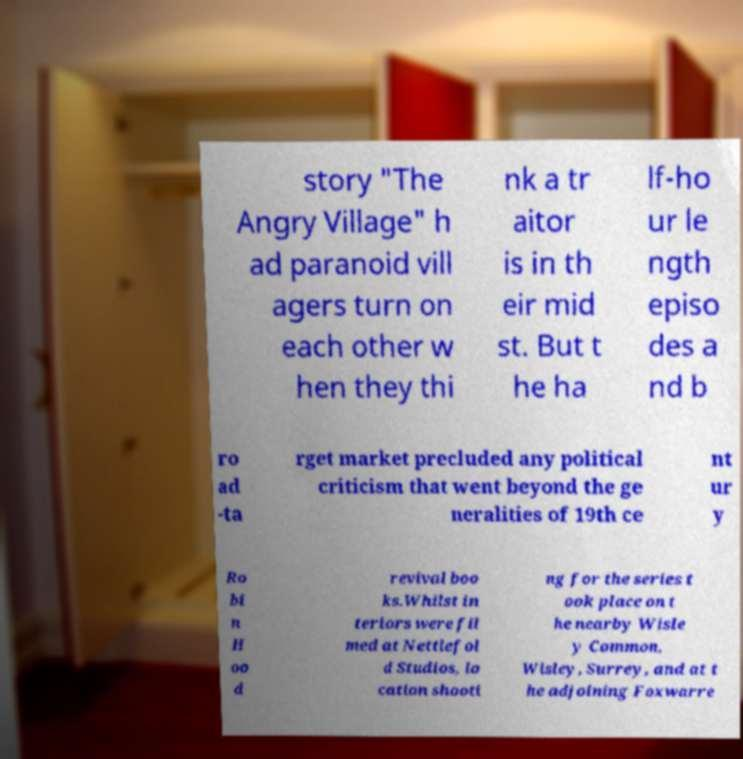Can you read and provide the text displayed in the image?This photo seems to have some interesting text. Can you extract and type it out for me? story "The Angry Village" h ad paranoid vill agers turn on each other w hen they thi nk a tr aitor is in th eir mid st. But t he ha lf-ho ur le ngth episo des a nd b ro ad -ta rget market precluded any political criticism that went beyond the ge neralities of 19th ce nt ur y Ro bi n H oo d revival boo ks.Whilst in teriors were fil med at Nettlefol d Studios, lo cation shooti ng for the series t ook place on t he nearby Wisle y Common, Wisley, Surrey, and at t he adjoining Foxwarre 